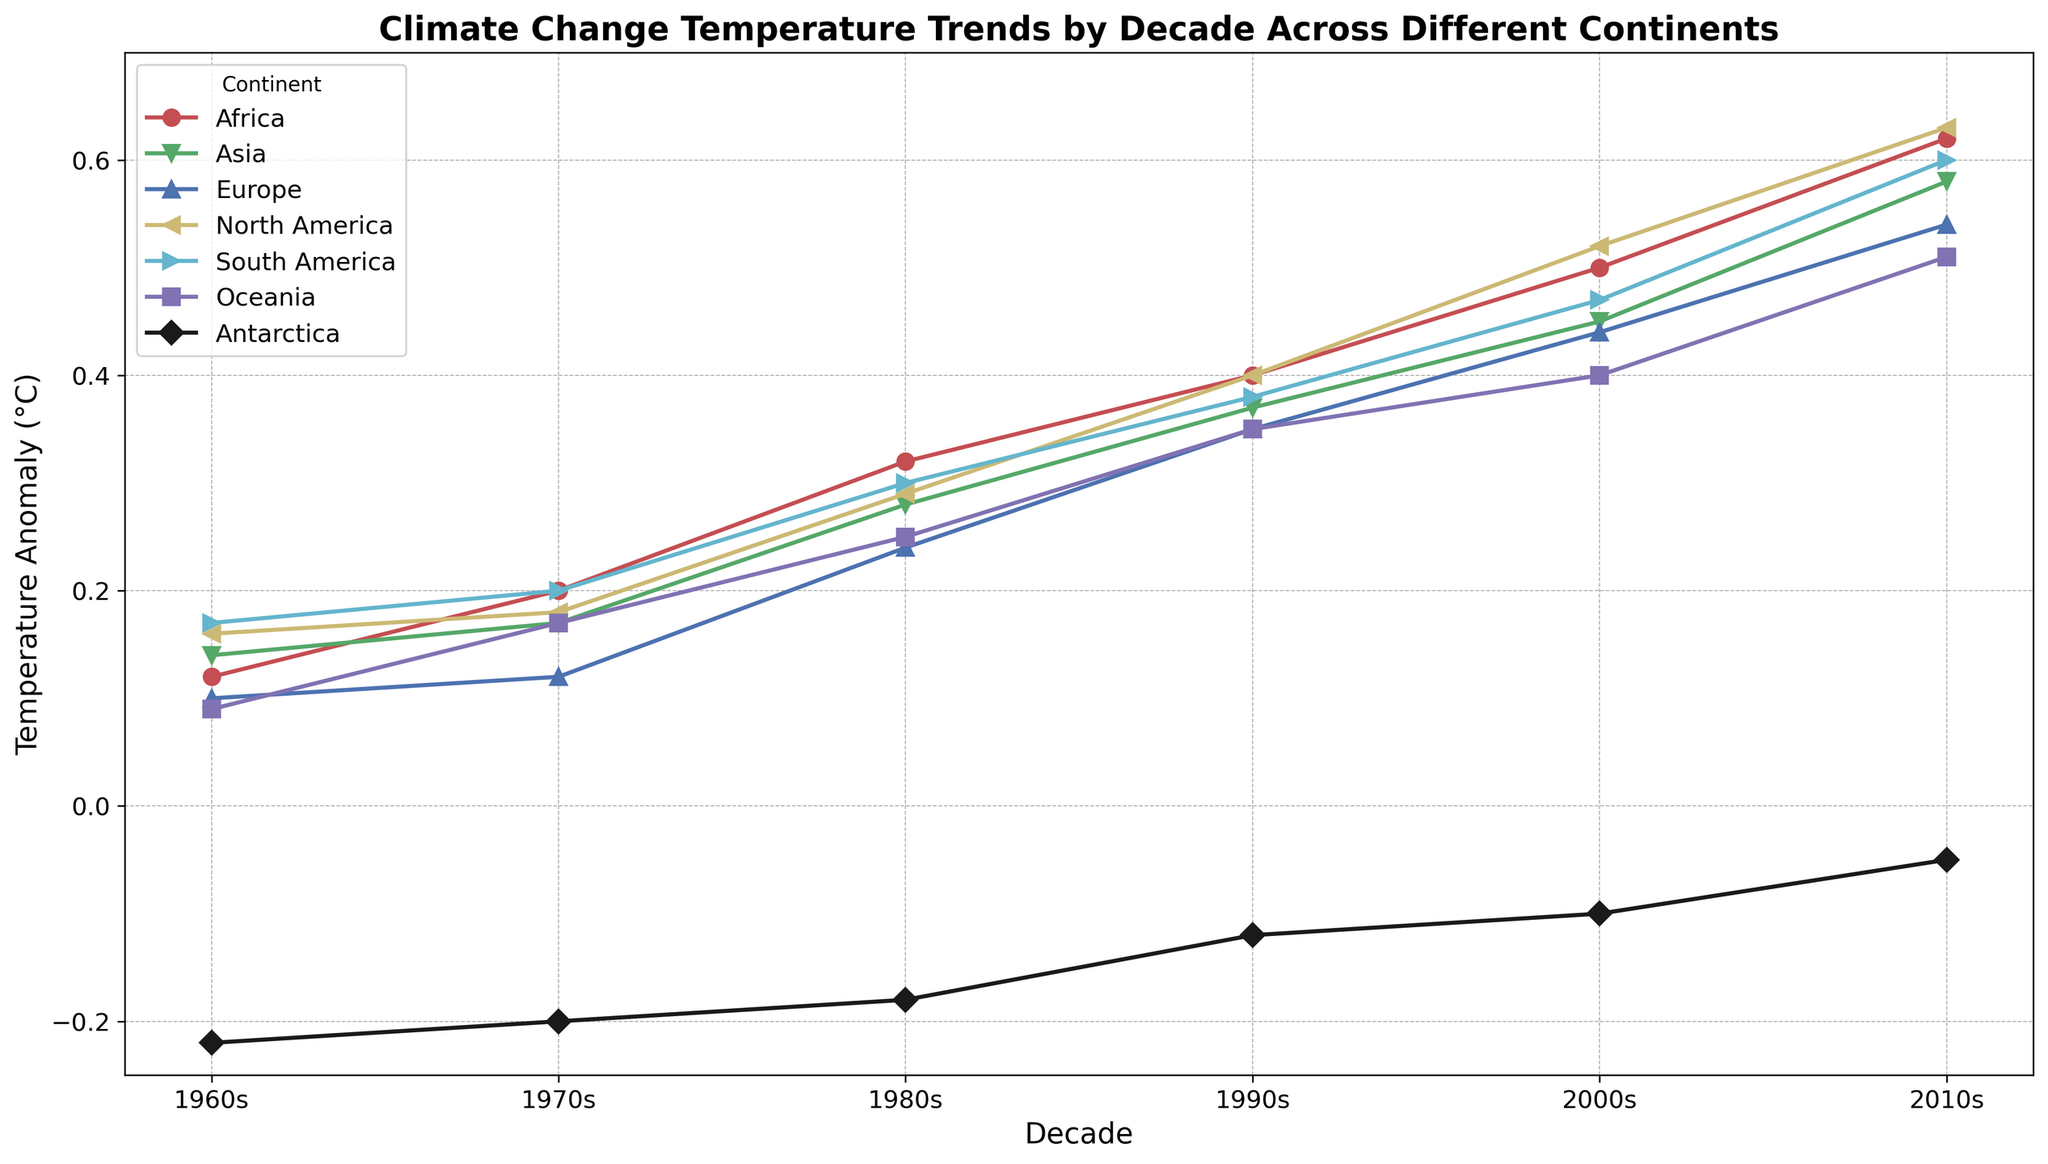what's the decade with the highest temperature anomaly for North America? To determine the decade with the highest temperature anomaly for North America, locate the North America line (yellow color with '<' marker) and identify the highest point on the graph. The highest temperature anomaly for North America occurs in the 2010s.
Answer: 2010s which continent showed a decrease in temperature anomaly from the 1960s to the 2010s? Examine all continent lines and locate any descending trend from the 1960s to the 2010s. Only Antarctica (black color with 'D' marker) shows a decrease in temperature anomaly over this period.
Answer: Antarctica what is the difference in temperature anomaly between Africa and Europe in the 2000s? Find the points for Africa (red color with 'o' marker) and Europe (blue color with '^' marker) in the 2000s. The temperature anomalies are 0.50°C for Africa and 0.44°C for Europe. The difference is 0.50 - 0.44 = 0.06°C.
Answer: 0.06°C which two continents have the closest temperature anomalies in the 2010s? Locate the points for all continents in the 2010s. Find the pairs with minimum difference. Asia (0.58°C) and South America (0.60°C) are the closest with a difference of 0.02°C.
Answer: Asia and South America what's the average temperature anomaly of Oceania over the five decades? Extract the temperature anomalies for Oceania (magenta color with 's' marker) over all decades: 0.09, 0.17, 0.25, 0.35, 0.40, 0.51. The average is (0.09 + 0.17 + 0.25 + 0.35 + 0.40 + 0.51)/6 = 0.295°C.
Answer: 0.295°C which decade showed the largest increase in temperature anomaly for any continent? Determine the decade-to-decade changes for each continent. For North America, the change from the 2000s (0.52°C) to the 2010s (0.63°C) is 0.11°C. This is the largest increase among all continents and all decades.
Answer: 2000s to 2010s compare the temperature anomaly trends of Africa and Antarctica from the 1960s to the 2010s. Examine the respective lines. Africa (red color with 'o' marker) shows a steady increase from 0.12°C to 0.62°C. Antarctica (black color with 'D' marker) shows a small increase from -0.22°C to -0.05°C. In comparison, Africa has a much sharper upward trend than Antarctica.
Answer: Africa shows a sharper increase which continent had the smallest temperature anomaly during the 1990s? Look at the points in the 1990s for all continents. Antarctica (black color with 'D' marker) had the smallest anomaly at -0.12°C.
Answer: Antarctica what's the total increase in temperature anomaly for Europe from the 1960s to the 2010s? Locate Europe's (blue color with '^' marker) anomalies: from 0.10°C in the 1960s to 0.54°C in the 2010s. The total increase is 0.54 - 0.10 = 0.44°C.
Answer: 0.44°C is there any decade where the temperature anomaly for South America was lower than for Oceania? Compare South America (cyan color with '>' marker) and Oceania (magenta color with 's' marker) for each decade. In all decades, the temperature anomaly for South America is higher than Oceania.
Answer: No 